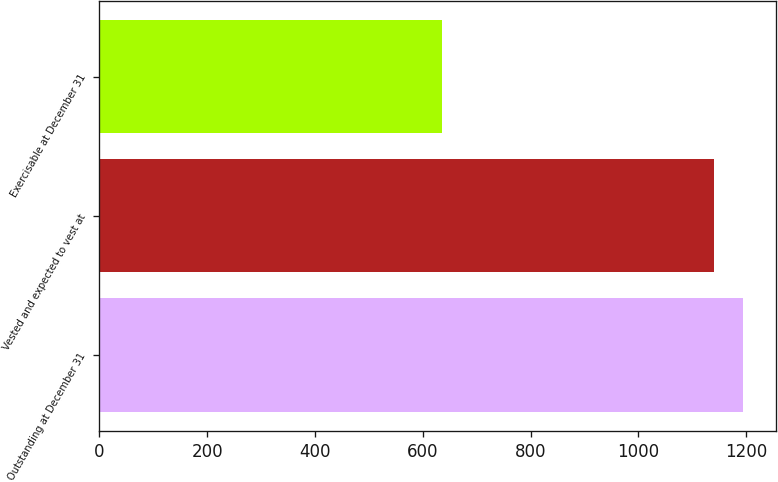Convert chart to OTSL. <chart><loc_0><loc_0><loc_500><loc_500><bar_chart><fcel>Outstanding at December 31<fcel>Vested and expected to vest at<fcel>Exercisable at December 31<nl><fcel>1194.8<fcel>1140<fcel>636<nl></chart> 